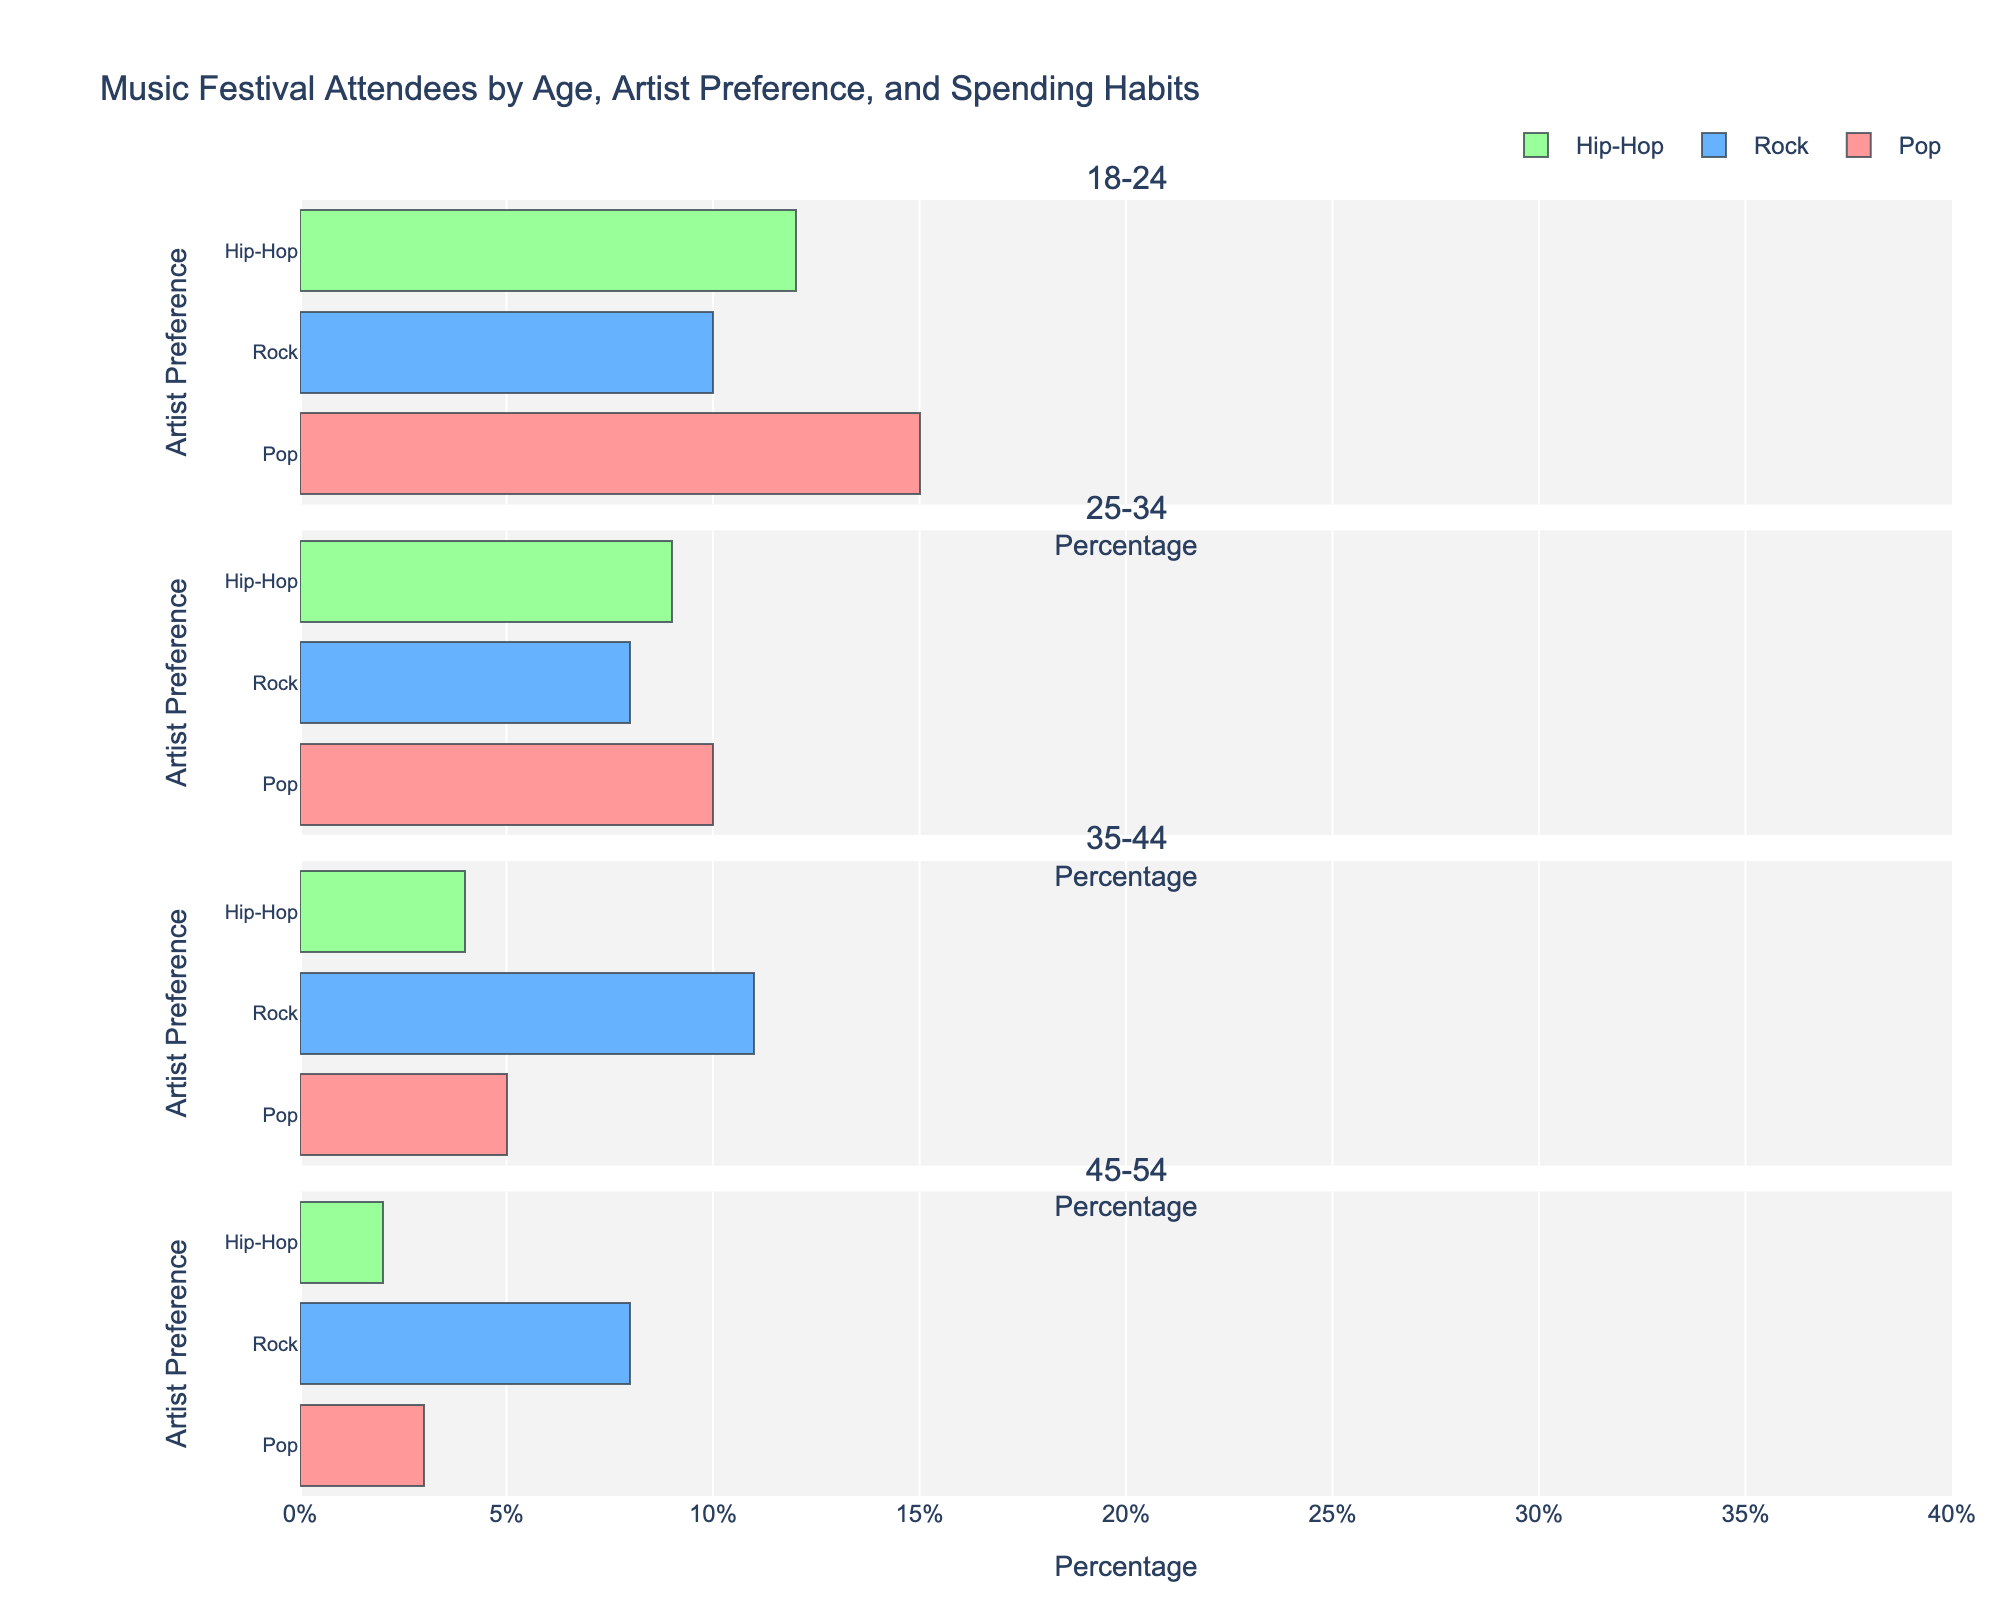What is the most preferred artist genre among the 18-24 age group? In the figure, look at the row for the 18-24 age group and compare the total length of the bars for each genre. The genre with the longest bar is the most preferred.
Answer: Pop Which spending category has the highest percentage for Hip-Hop fans aged 35-44? Navigate to the section of the figure for the 35-44 age group and identify the bar for Hip-Hop. Compare the segments within this bar for Low, Medium, and High spending categories. The segment with the largest length is the answer.
Answer: Low (Below $100) What is the combined percentage of attendees aged 25-34 who prefer Rock and spend either a medium or high amount? Focus on the Rock preference bar for the 25-34 age group. Add the percentages for Medium ($100-$300) and High (Above $300) spending categories.
Answer: 17% How does the spending behavior for Pop music compare between the 18-24 and 45-54 age groups? Compare the bars for Pop preference in the 18-24 and 45-54 age groups. Notice the differences in the heights of the Low, Medium, and High segments in each bar.
Answer: The 18-24 age group spends more across all categories Which age group has the lowest percentage of attendees who prefer Hip-Hop and high spending? Look at the Hip-Hop preference bars for each age group and identify the smallest segment in the High (Above $300) spending category.
Answer: 45-54 Compare the total percentage of Rock fans aged 35-44 to the total percentage of Pop fans in the same age group. Sum the percentages for Low, Medium, and High spending categories for both Rock and Pop preferences within the 35-44 age group. Compare these sums.
Answer: Rock has a higher total percentage How does the spending habit for Rock fans aged 45-54 differ between the Low and Medium categories? Examine the Rock preference bar for the 45-54 age group and compare the lengths of the Low (Below $100) and Medium ($100-$300) segments.
Answer: Low is higher Which genre and spending category combination has the highest percentage for the 25-34 age group? For the 25-34 age group, observe all genres and spending categories in the bar chart. Identify the segment with the greatest length.
Answer: Pop, Medium ($100-$300) What is the difference in percentage between Pop and Hip-Hop fans aged 18-24 who spend a low amount? Compare the lengths of the Low (Below $100) segments for Pop and Hip-Hop preferences in the 18-24 age group. Subtract the Hip-Hop percentage from the Pop percentage.
Answer: 3% For the 35-44 age group, identify the spending category with the least difference in percentage between Pop and Rock fans. Compare the lengths of the Low, Medium, and High spending segments for Pop and Rock preferences in the 35-44 age group. Find the spending category where the difference between the segment lengths is smallest.
Answer: High (Above $300) 